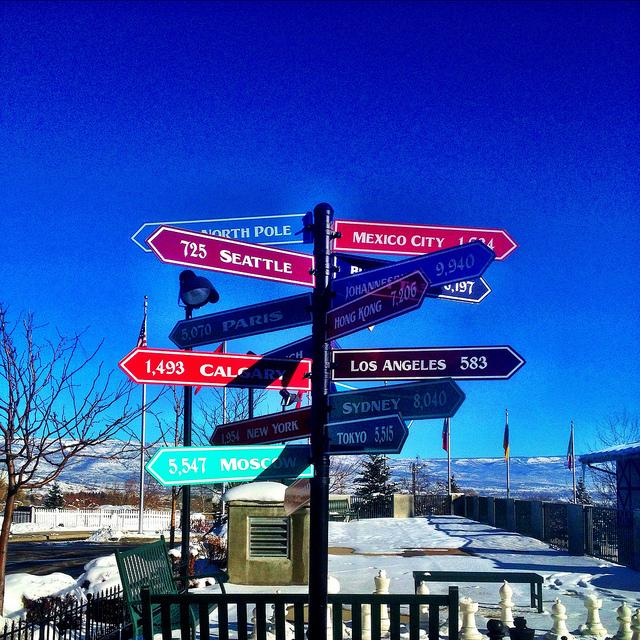What kind of locations are mentioned in the signs? Please explain your reasoning. cities. The locations are places like calgary, tokyo, and sydney. these are not countries, cardinal points, or continents. 